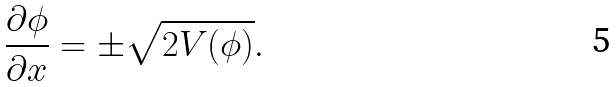<formula> <loc_0><loc_0><loc_500><loc_500>\frac { \partial \phi } { \partial x } = \pm \sqrt { 2 V ( \phi ) } .</formula> 